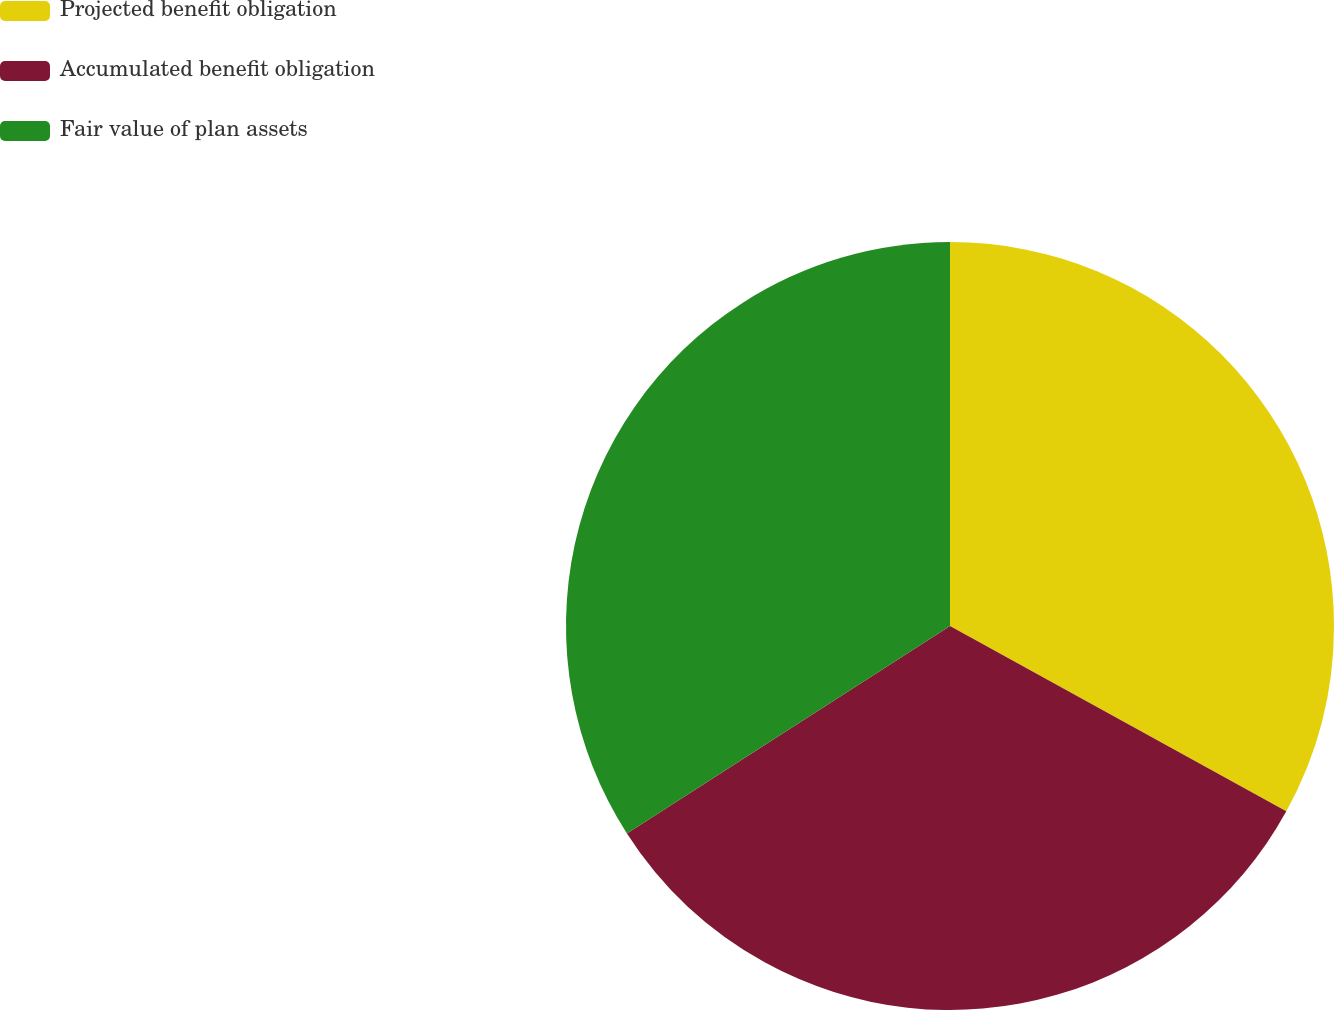<chart> <loc_0><loc_0><loc_500><loc_500><pie_chart><fcel>Projected benefit obligation<fcel>Accumulated benefit obligation<fcel>Fair value of plan assets<nl><fcel>33.02%<fcel>32.9%<fcel>34.09%<nl></chart> 